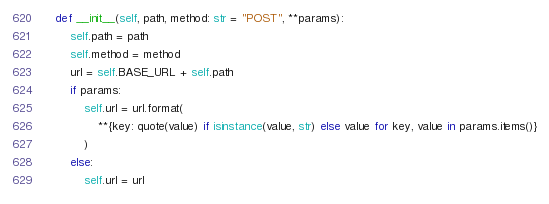Convert code to text. <code><loc_0><loc_0><loc_500><loc_500><_Python_>
    def __init__(self, path, method: str = "POST", **params):
        self.path = path
        self.method = method
        url = self.BASE_URL + self.path
        if params:
            self.url = url.format(
                **{key: quote(value) if isinstance(value, str) else value for key, value in params.items()}
            )
        else:
            self.url = url
</code> 